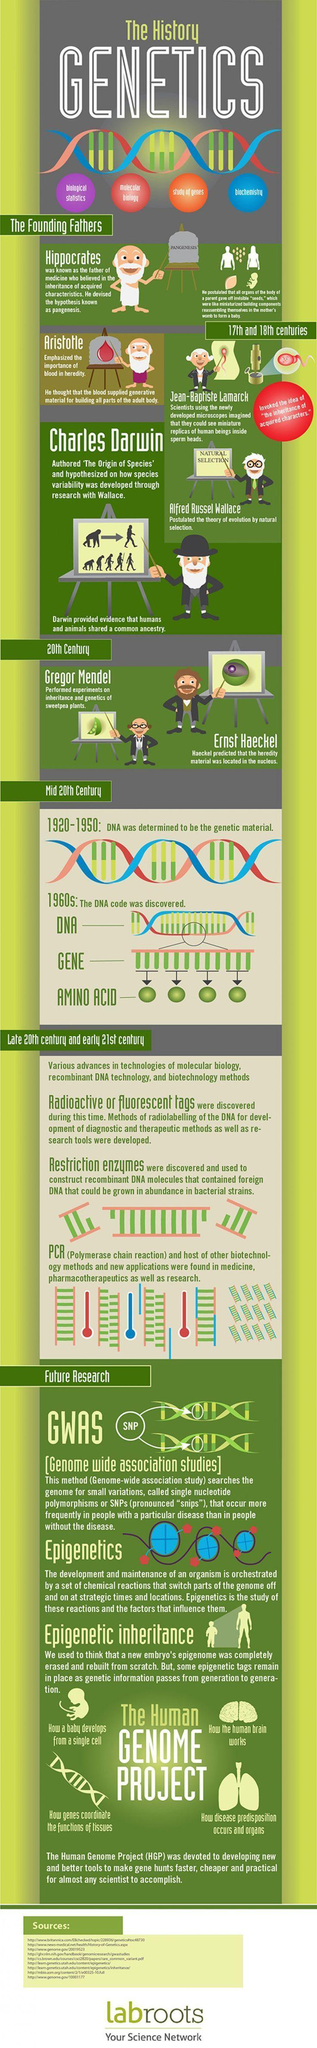Draw attention to some important aspects in this diagram. Aristotle believed that blood supplied the generative material for building all parts of the adult body. The scientists in the 20th century include Gregor Mendel and Ernst Haeckel. The backrest of the chair is inscribed with the word 'Pangenesis.' Restriction enzymes were discovered in the late 20th century and early 21st century. 